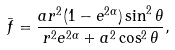Convert formula to latex. <formula><loc_0><loc_0><loc_500><loc_500>\bar { f } = \frac { a r ^ { 2 } ( 1 - e ^ { 2 \alpha } ) \sin ^ { 2 } \theta } { r ^ { 2 } e ^ { 2 \alpha } + a ^ { 2 } \cos ^ { 2 } \theta } ,</formula> 